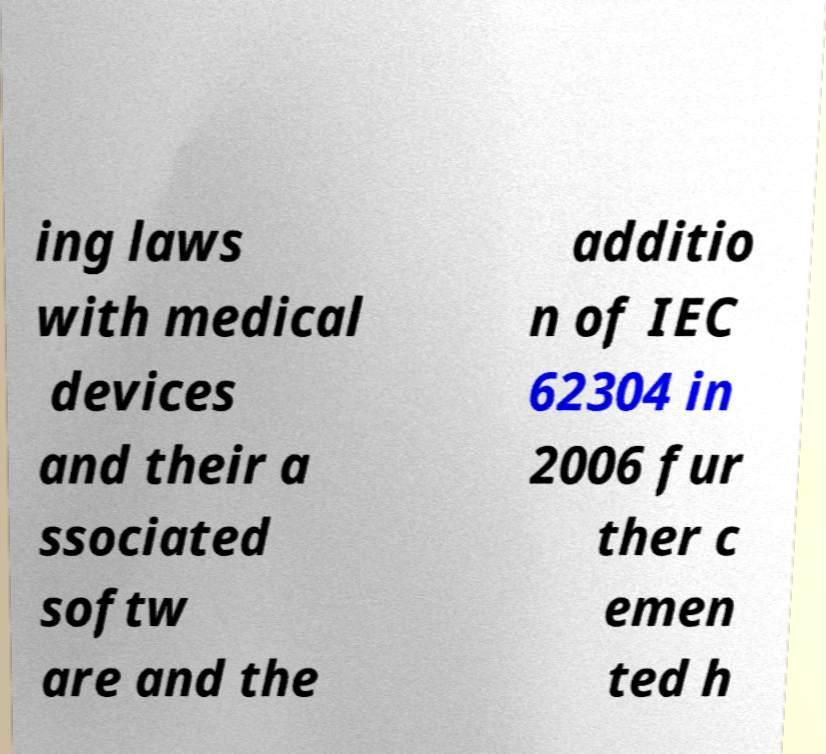Please read and relay the text visible in this image. What does it say? ing laws with medical devices and their a ssociated softw are and the additio n of IEC 62304 in 2006 fur ther c emen ted h 